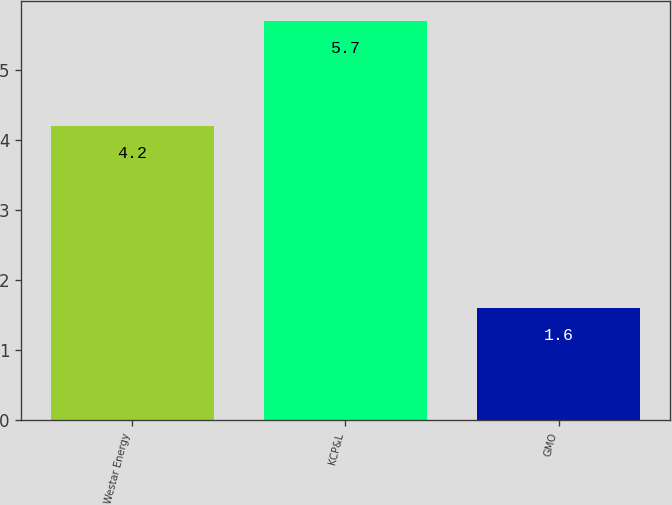<chart> <loc_0><loc_0><loc_500><loc_500><bar_chart><fcel>Westar Energy<fcel>KCP&L<fcel>GMO<nl><fcel>4.2<fcel>5.7<fcel>1.6<nl></chart> 